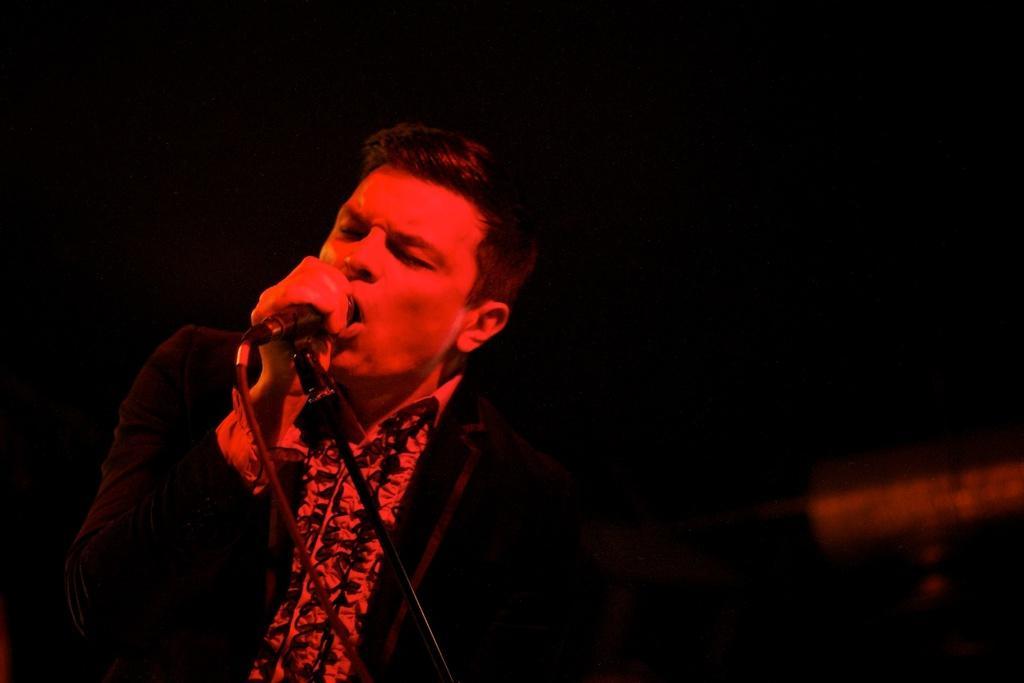Could you give a brief overview of what you see in this image? In this image I can see the person and the person is holding a microphone and singing and I can see the dark background. 